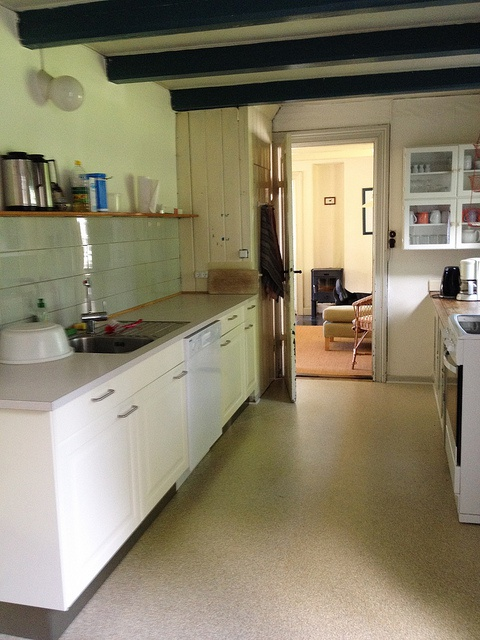Describe the objects in this image and their specific colors. I can see oven in gray and darkgray tones, sink in gray, black, darkgreen, and maroon tones, chair in gray, olive, maroon, and ivory tones, chair in gray, maroon, and tan tones, and bottle in gray, black, olive, and maroon tones in this image. 